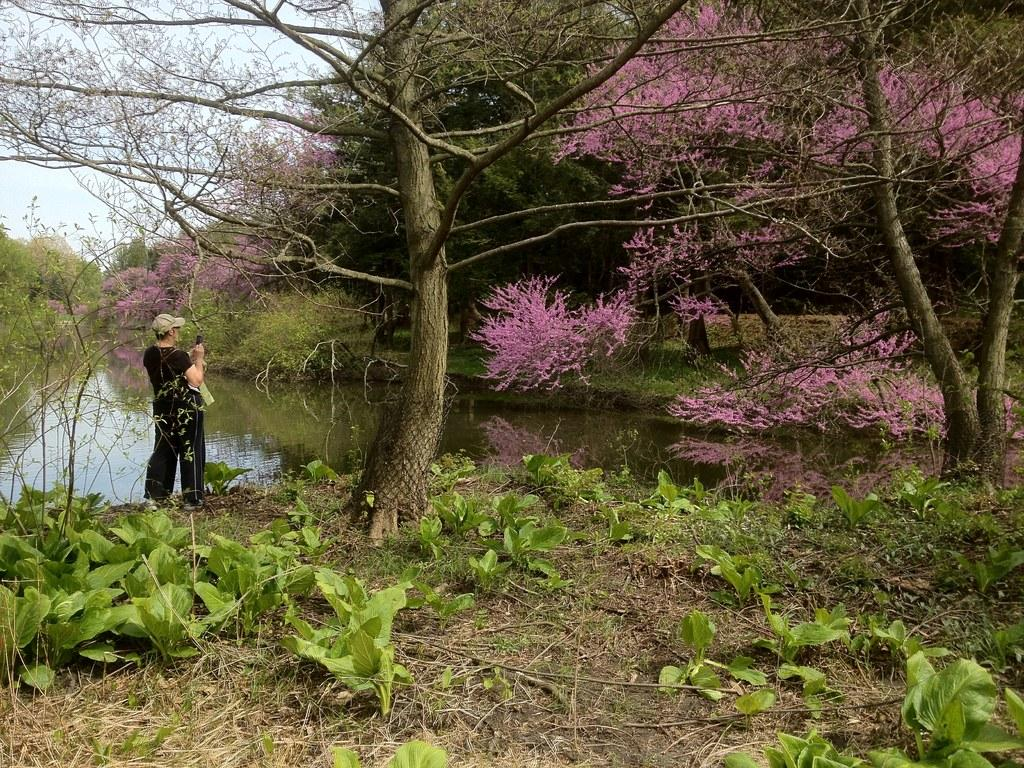What type of vegetation can be seen in the image? There is grass and trees in the image. What is the man in the image doing? The man is standing in the image. What can be seen in the water in the image? The facts do not specify what can be seen in the water. What is visible at the top of the image? The sky is visible at the top of the image. Where is the stone house located in the image? There is no stone house present in the image. How does the man plan to join the group of people in the image? The facts do not mention any group of people or the man's intention to join them. 